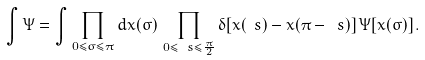Convert formula to latex. <formula><loc_0><loc_0><loc_500><loc_500>\int \Psi = \int \prod _ { 0 \leq \sigma \leq \pi } d x ( \sigma ) \, \prod _ { 0 \leq \ s \leq \frac { \pi } { 2 } } \delta [ x ( \ s ) - x ( \pi - \ s ) ] \, \Psi [ x ( \sigma ) ] \, .</formula> 